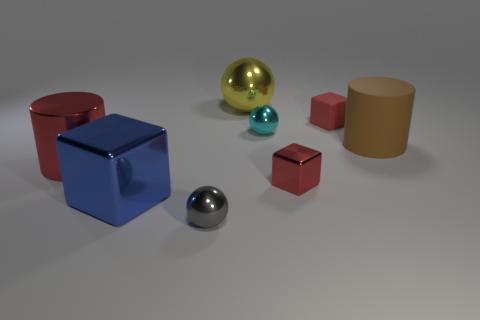Imagine these objects are part of a children's toy set. What sort of game could they be used for? These objects could be part of a creative building game where children stack and balance them in various ways to construct structures. The difference in sizes and shapes can make the game challenging and engaging, encouraging hand-eye coordination and spatial reasoning. 